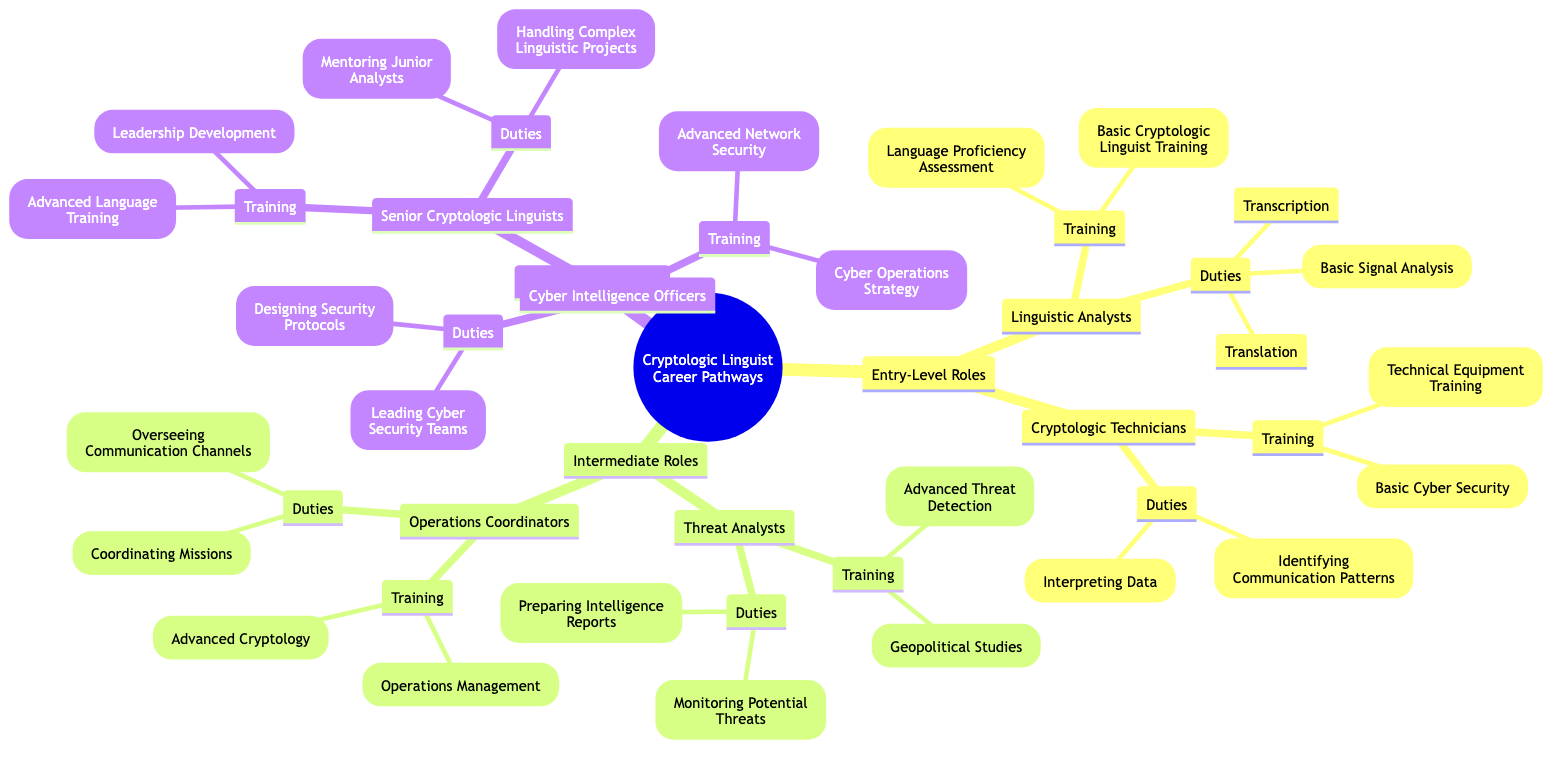What are the entry-level roles in the cryptologic linguist career? The diagram states the entry-level roles as Linguistic Analysts and Cryptologic Technicians, which are directly labeled under the "Entry-Level Roles" node.
Answer: Linguistic Analysts, Cryptologic Technicians What training do Cryptologic Technicians receive? Looking at the "Cryptologic Technicians" node, the training is listed as Technical Equipment Training and Basic Cyber Security.
Answer: Technical Equipment Training, Basic Cyber Security How many intermediate roles are shown in the diagram? By counting the nodes under "Intermediate Roles," we find two roles: Threat Analysts and Operations Coordinators.
Answer: 2 What is one duty of Threat Analysts? In the "Threat Analysts" section, the duties are specified, including Monitoring Potential Threats and Preparing Intelligence Reports. Therefore, one of the duties is Monitoring Potential Threats.
Answer: Monitoring Potential Threats Which advanced specialist role handles complex linguistic projects? Referring to the "Senior Cryptologic Linguists" node under "Advanced Specialists," it specifically states that handling complex linguistic projects is one of their duties.
Answer: Senior Cryptologic Linguists What type of training do Senior Cryptologic Linguists undergo? The training for Senior Cryptologic Linguists is directly listed under their section as Leadership Development and Advanced Language Training.
Answer: Leadership Development, Advanced Language Training What is the primary duty of Cyber Intelligence Officers? In the "Cyber Intelligence Officers" section, the major duty is leading Cyber Security Teams, clearly stated among their duties.
Answer: Leading Cyber Security Teams Which roles involve overseeing communication channels? In the "Operations Coordinators" section, one duty highlighted is Overseeing Communication Channels, distinguishing this role in this context.
Answer: Operations Coordinators 